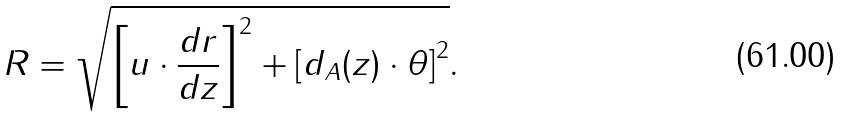<formula> <loc_0><loc_0><loc_500><loc_500>R = \sqrt { \left [ u \cdot \frac { d r } { d z } \right ] ^ { 2 } + \left [ d _ { A } ( z ) \cdot \theta \right ] ^ { 2 } } .</formula> 